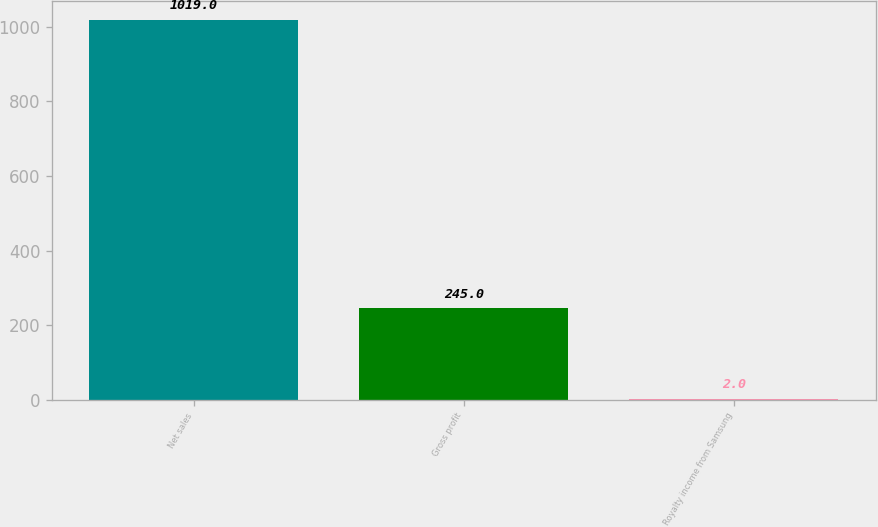Convert chart. <chart><loc_0><loc_0><loc_500><loc_500><bar_chart><fcel>Net sales<fcel>Gross profit<fcel>Royalty income from Samsung<nl><fcel>1019<fcel>245<fcel>2<nl></chart> 